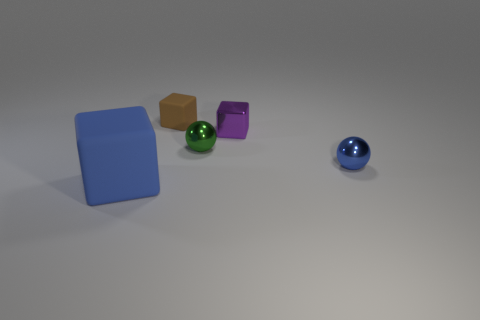Are there the same number of cubes on the left side of the green metallic object and tiny shiny things behind the small blue thing?
Provide a succinct answer. Yes. Is there any other thing that is the same size as the blue cube?
Give a very brief answer. No. How many brown objects are small matte things or shiny balls?
Provide a short and direct response. 1. What number of other blue objects have the same size as the blue shiny object?
Keep it short and to the point. 0. What color is the object that is both left of the tiny metal cube and on the right side of the tiny brown rubber block?
Your answer should be compact. Green. Is the number of matte things that are to the right of the big matte thing greater than the number of small green metal blocks?
Provide a succinct answer. Yes. Are any large yellow matte objects visible?
Ensure brevity in your answer.  No. How many tiny things are metal blocks or brown matte objects?
Give a very brief answer. 2. Is there any other thing that is the same color as the big rubber thing?
Offer a terse response. Yes. There is a tiny purple object that is the same material as the blue sphere; what is its shape?
Keep it short and to the point. Cube. 